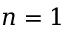<formula> <loc_0><loc_0><loc_500><loc_500>n = 1</formula> 